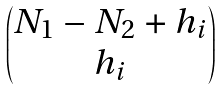<formula> <loc_0><loc_0><loc_500><loc_500>\begin{pmatrix} N _ { 1 } - N _ { 2 } + h _ { i } \\ h _ { i } \end{pmatrix}</formula> 